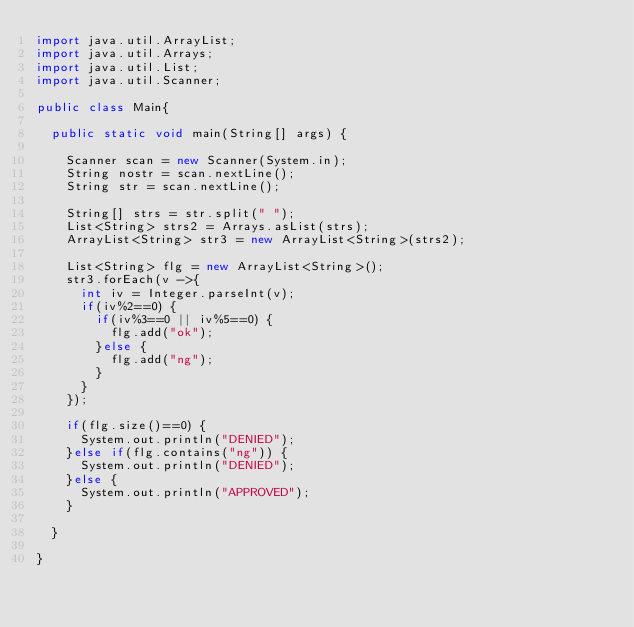Convert code to text. <code><loc_0><loc_0><loc_500><loc_500><_Java_>import java.util.ArrayList;
import java.util.Arrays;
import java.util.List;
import java.util.Scanner;

public class Main{

	public static void main(String[] args) {
	
		Scanner scan = new Scanner(System.in);
		String nostr = scan.nextLine();
		String str = scan.nextLine();
		
		String[] strs = str.split(" ");
		List<String> strs2 = Arrays.asList(strs);
		ArrayList<String> str3 = new ArrayList<String>(strs2);
		
		List<String> flg = new ArrayList<String>();
		str3.forEach(v ->{
			int iv = Integer.parseInt(v);
			if(iv%2==0) {
				if(iv%3==0 || iv%5==0) {
					flg.add("ok");
				}else {
					flg.add("ng");
				}
			}
		});
		
		if(flg.size()==0) {
			System.out.println("DENIED");
		}else if(flg.contains("ng")) {
			System.out.println("DENIED");
		}else {
			System.out.println("APPROVED");
		}

	}

}</code> 